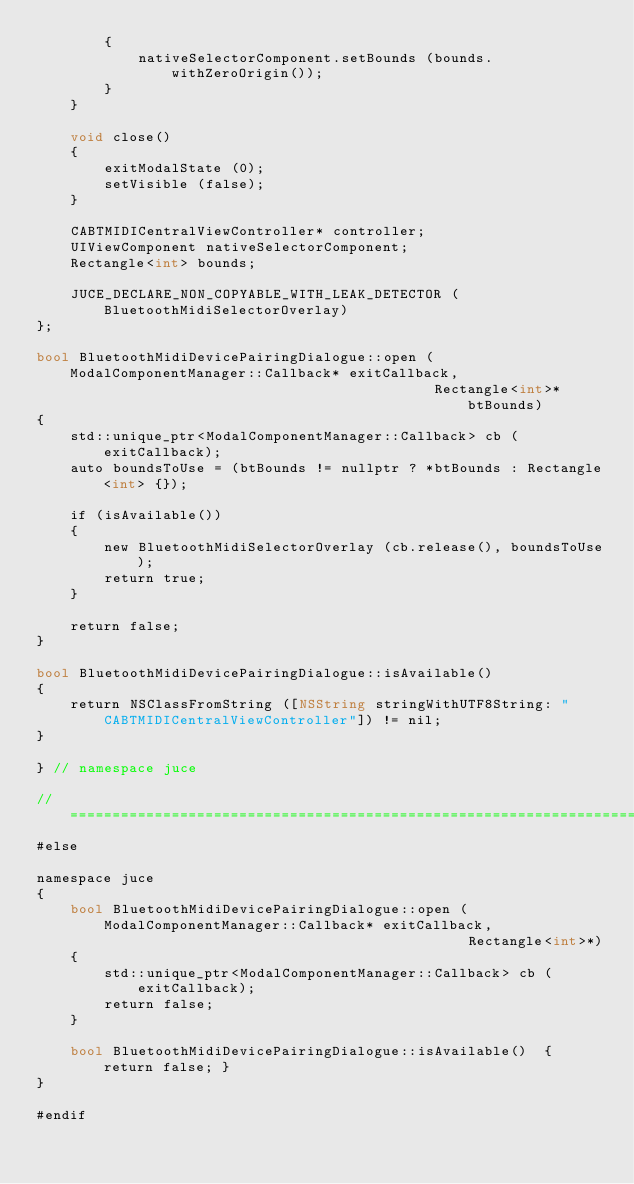Convert code to text. <code><loc_0><loc_0><loc_500><loc_500><_ObjectiveC_>        {
            nativeSelectorComponent.setBounds (bounds.withZeroOrigin());
        }
    }

    void close()
    {
        exitModalState (0);
        setVisible (false);
    }

    CABTMIDICentralViewController* controller;
    UIViewComponent nativeSelectorComponent;
    Rectangle<int> bounds;

    JUCE_DECLARE_NON_COPYABLE_WITH_LEAK_DETECTOR (BluetoothMidiSelectorOverlay)
};

bool BluetoothMidiDevicePairingDialogue::open (ModalComponentManager::Callback* exitCallback,
                                               Rectangle<int>* btBounds)
{
    std::unique_ptr<ModalComponentManager::Callback> cb (exitCallback);
    auto boundsToUse = (btBounds != nullptr ? *btBounds : Rectangle<int> {});

    if (isAvailable())
    {
        new BluetoothMidiSelectorOverlay (cb.release(), boundsToUse);
        return true;
    }

    return false;
}

bool BluetoothMidiDevicePairingDialogue::isAvailable()
{
    return NSClassFromString ([NSString stringWithUTF8String: "CABTMIDICentralViewController"]) != nil;
}

} // namespace juce

//==============================================================================
#else

namespace juce
{
    bool BluetoothMidiDevicePairingDialogue::open (ModalComponentManager::Callback* exitCallback,
                                                   Rectangle<int>*)
    {
        std::unique_ptr<ModalComponentManager::Callback> cb (exitCallback);
        return false;
    }

    bool BluetoothMidiDevicePairingDialogue::isAvailable()  { return false; }
}

#endif
</code> 